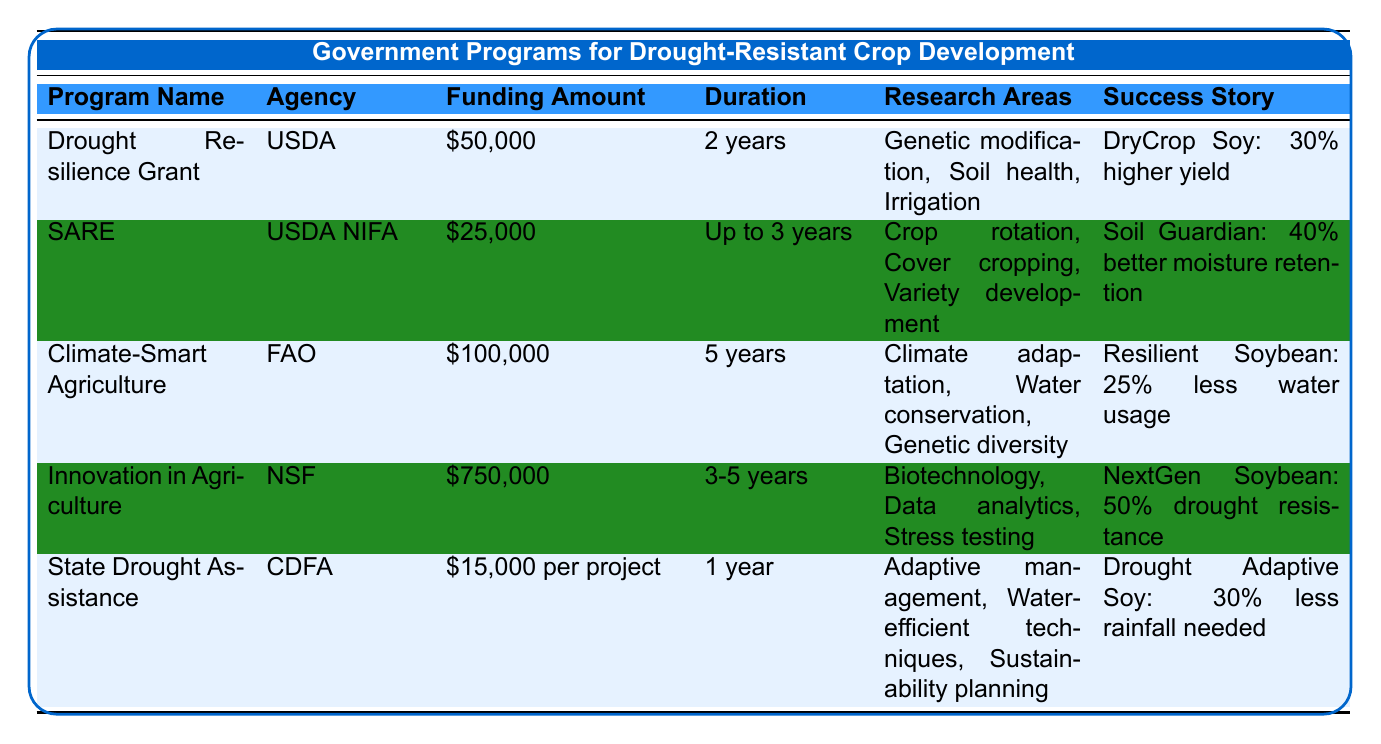What is the total funding amount offered by the Climate-Smart Agriculture Program? The Climate-Smart Agriculture Program offers a single funding amount of $100,000, as stated in the table under the "Funding Amount" column for that program.
Answer: $100,000 Which agency administers the Drought Resilience Grant? The Drought Resilience Grant is administered by the U.S. Department of Agriculture (USDA) as indicated in the "Agency" column for that program.
Answer: USDA What is the duration of the State Drought Assistance Program? The duration of the State Drought Assistance Program is listed as 1 year in the table under the "Duration" column for that program.
Answer: 1 year Which program has the highest funding amount? By comparing the funding amounts across all programs, the Innovation in Agriculture Program has the highest at $750,000, which is indicated in the corresponding row under the "Funding Amount" column.
Answer: $750,000 Do all programs include a success story? Yes, each program listed in the table has a corresponding success story, as shown under the "Success Story" column for each program.
Answer: Yes What are the eligible research areas for the Sustainable Agriculture Research and Education program? The eligible research areas for the Sustainable Agriculture Research and Education program can be found in the "Research Areas" column, which includes crop rotation practices, cover cropping, and drought-resistant variety development.
Answer: Crop rotation, cover cropping, drought-resistant variety development What is the average funding amount across all programs? To find the average funding amount, convert each funding amount to a numerical value: $50,000, $25,000, $100,000, $750,000, and $15,000. Sum them (50,000 + 25,000 + 100,000 + 750,000 + 15,000 = 940,000) and divide by the number of programs (5), resulting in an average of $188,000.
Answer: $188,000 What is the outcome of the NextGen Soybean project? The outcome of the NextGen Soybean project, listed under the success stories of the Innovation in Agriculture Program, is that it developed a soybean variant with 50% drought resistance. This information can be found in the "Success Story" column.
Answer: 50% drought resistance How many programs focus on genetic modification or biotechnology? Three programs focus on genetic modification or biotechnology: Drought Resilience Grant, Climate-Smart Agriculture Program, and Innovation in Agriculture Program. Therefore, count these specific programs and present the total.
Answer: 3 Do any programs offer technical assistance as part of their incentives? Yes, the Sustainable Agriculture Research and Education program provides technical assistance, as indicated in the "Incentives" section of that program in the table.
Answer: Yes What is the difference in funding between the highest and lowest funding programs? The highest funding program is Innovation in Agriculture Program ($750,000) and the lowest is the State Drought Assistance Program ($15,000). Calculate the difference (750,000 - 15,000 = 735,000) to find the numerical difference in funding.
Answer: $735,000 